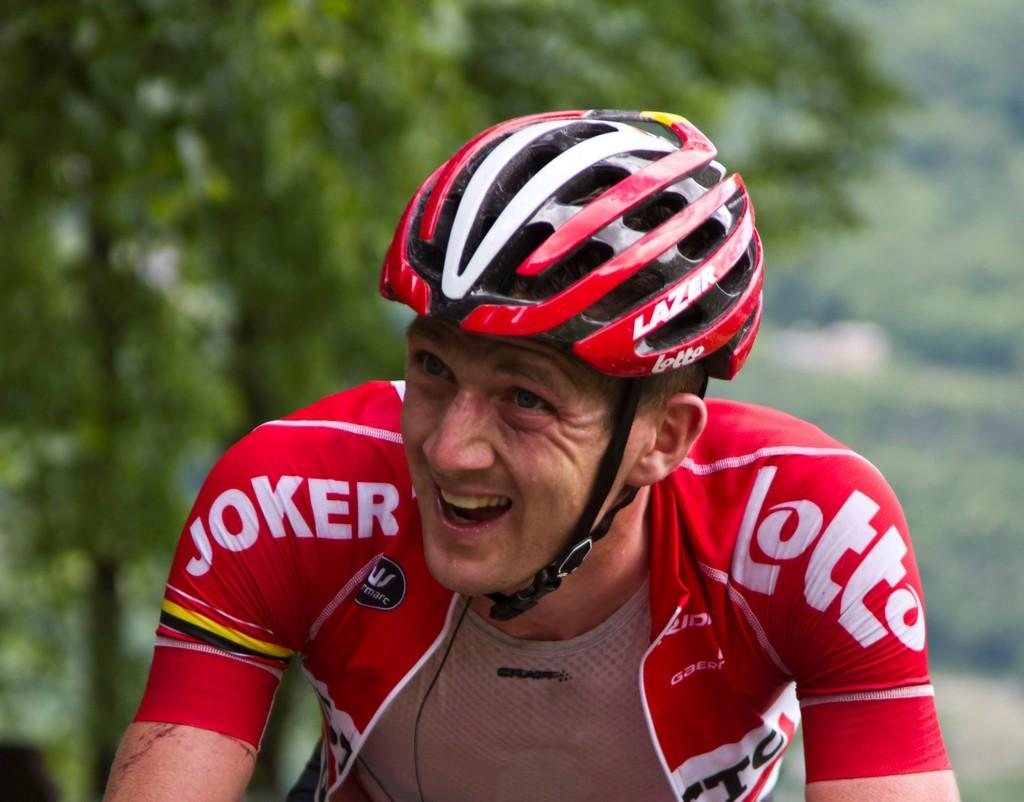Who is the main subject in the picture? There is a man in the middle of the picture. What is the man doing in the image? The man is smiling. What is the man wearing on his head? The man is wearing a helmet on his head. What can be seen in the background of the picture? There are trees in the background of the picture. How does the man touch the hose in the image? There is no hose present in the image, so it is not possible to answer a question about touching a hose. 